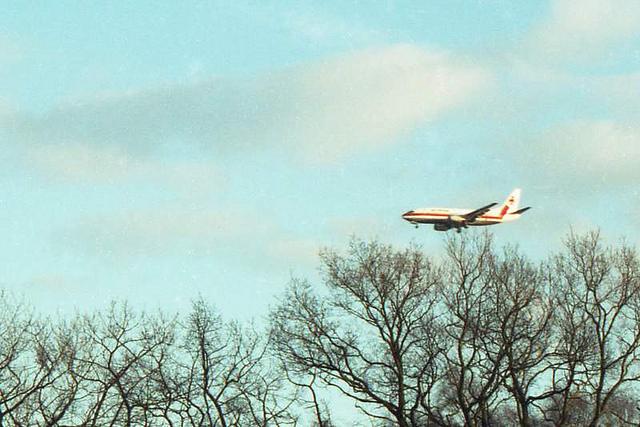Where is the plane going?
Concise answer only. West. What airline is this plane from?
Give a very brief answer. United. Is the sky blue?
Concise answer only. Yes. 